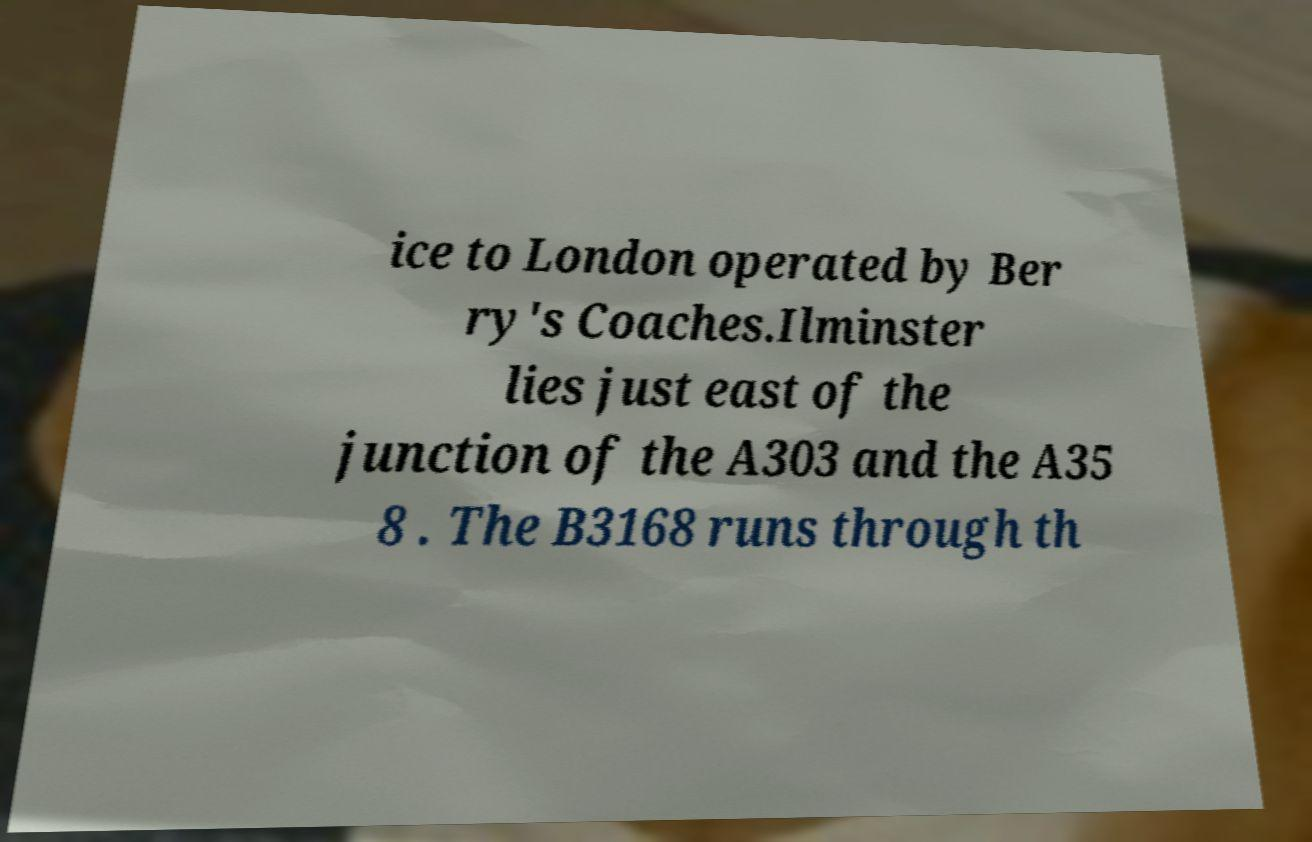There's text embedded in this image that I need extracted. Can you transcribe it verbatim? ice to London operated by Ber ry's Coaches.Ilminster lies just east of the junction of the A303 and the A35 8 . The B3168 runs through th 